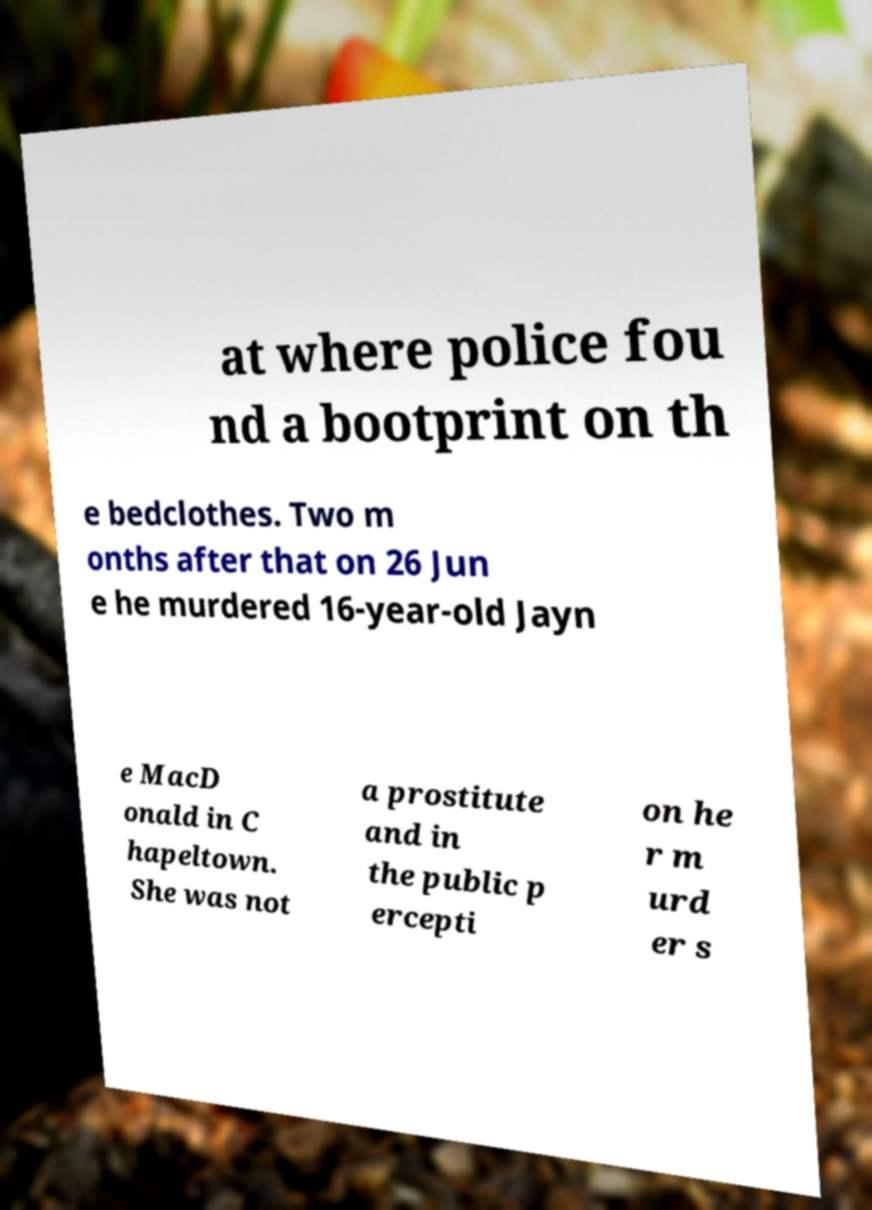Please identify and transcribe the text found in this image. at where police fou nd a bootprint on th e bedclothes. Two m onths after that on 26 Jun e he murdered 16-year-old Jayn e MacD onald in C hapeltown. She was not a prostitute and in the public p ercepti on he r m urd er s 